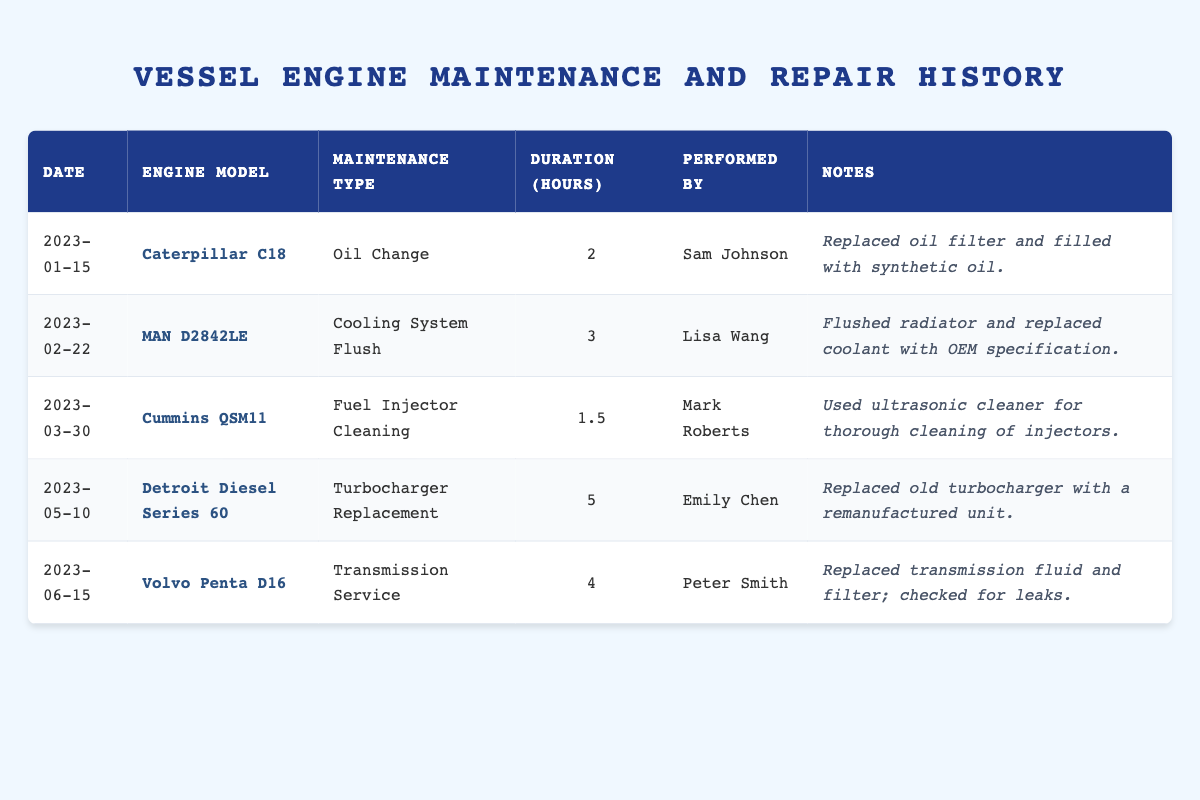What maintenance type was performed on the Caterpillar C18 engine? The table lists the maintenance history, and for the Caterpillar C18, it shows "Oil Change" as the maintenance type conducted on the date of January 15, 2023.
Answer: Oil Change Who performed the turbocharger replacement for the Detroit Diesel Series 60? Looking at the table, the entry for the Detroit Diesel Series 60 indicates that Emily Chen was responsible for the turbocharger replacement on May 10, 2023.
Answer: Emily Chen How many hours did the cooling system flush take? The entry for the cooling system flush for the MAN D2842LE engine indicates it took 3 hours on February 22, 2023.
Answer: 3 hours Which maintenance activity took the longest duration and how many hours did it take? By examining the duration hours for all maintenance activities, the turbocharger replacement for the Detroit Diesel Series 60 took the longest duration of 5 hours on May 10, 2023.
Answer: 5 hours True or False: Mark Roberts performed a fuel injector cleaning within 2 hours? The table shows that Mark Roberts performed the fuel injector cleaning for the Cummins QSM11 on March 30, 2023, which took 1.5 hours; therefore, the statement is true.
Answer: True How many different engine models received maintenance in the first half of 2023? The table lists maintenance activities for 5 different engine models (Caterpillar C18, MAN D2842LE, Cummins QSM11, Detroit Diesel Series 60, and Volvo Penta D16) in the first half of 2023, which confirms each model is unique.
Answer: 5 models What is the average duration of maintenance across all listed services? To calculate the average duration, sum the durations (2 + 3 + 1.5 + 5 + 4 = 15.5 hours) and divide by the number of services (5), resulting in 15.5 / 5 = 3.1 hours.
Answer: 3.1 hours Which maintenance type did not involve any fluid replacement? Reviewing the notes reveals that the "Fuel Injector Cleaning" conducted by Mark Roberts for the Cummins QSM11 engine on March 30, 2023, does not mention fluid replacement, making it the only type listed without such an action.
Answer: Fuel Injector Cleaning How many services did Sam Johnson perform? Sam Johnson is noted as the performer of maintenance only for the oil change on January 15, 2023, indicating he conducted 1 service.
Answer: 1 service 